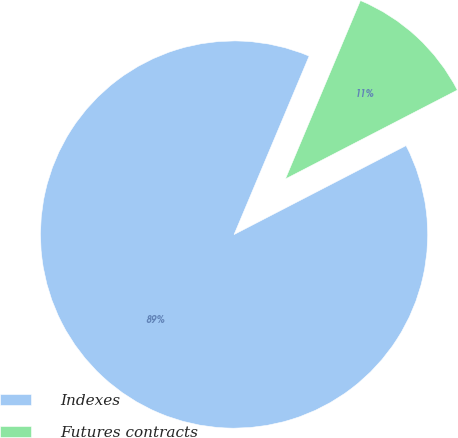<chart> <loc_0><loc_0><loc_500><loc_500><pie_chart><fcel>Indexes<fcel>Futures contracts<nl><fcel>88.93%<fcel>11.07%<nl></chart> 